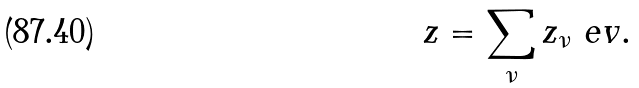Convert formula to latex. <formula><loc_0><loc_0><loc_500><loc_500>z = \sum _ { \nu } z _ { \nu } \ e v .</formula> 